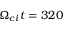<formula> <loc_0><loc_0><loc_500><loc_500>\Omega _ { c i } t = 3 2 0</formula> 